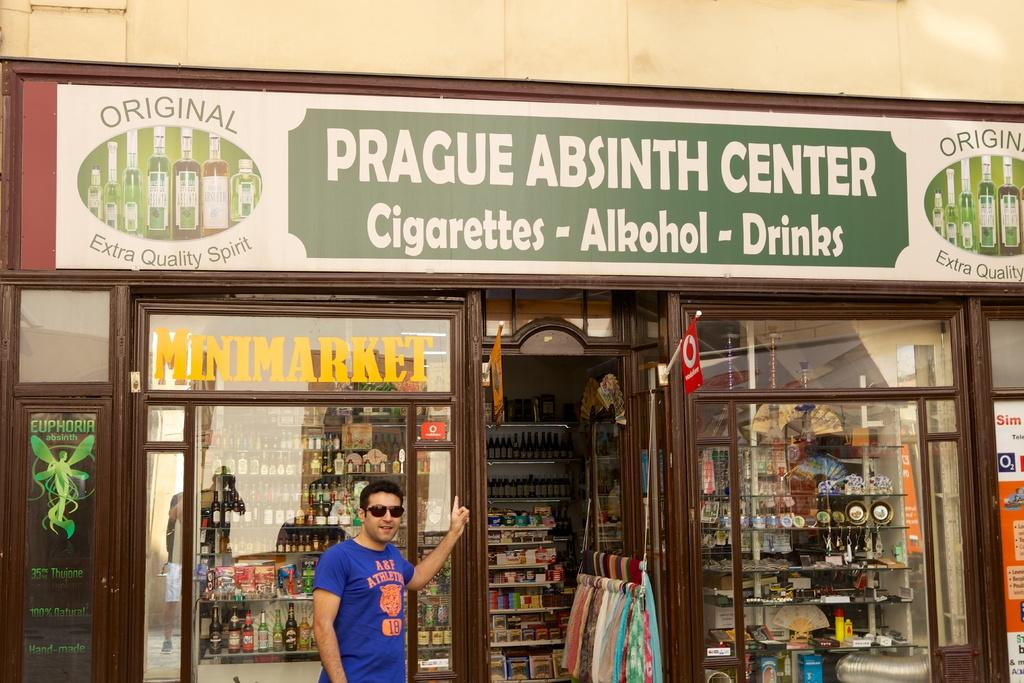<image>
Render a clear and concise summary of the photo. Prague Absinth Center specialized for Cigarettes alcohol and liquors 